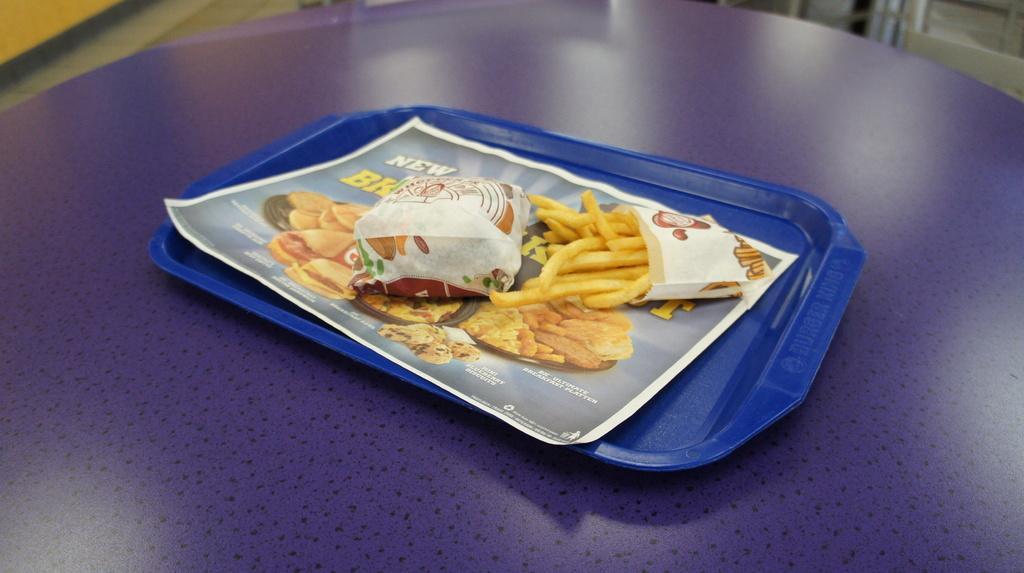How would you summarize this image in a sentence or two? In this image we can see a table, on the table, we can see a plate with some food and also we can see a poster with some text and images. 